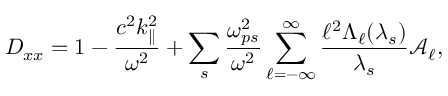Convert formula to latex. <formula><loc_0><loc_0><loc_500><loc_500>D _ { x x } = 1 - \frac { c ^ { 2 } k _ { \| } ^ { 2 } } { \omega ^ { 2 } } + \sum _ { s } \frac { \omega _ { p s } ^ { 2 } } { \omega ^ { 2 } } \sum _ { \ell = - \infty } ^ { \infty } \frac { \ell ^ { 2 } \Lambda _ { \ell } ( \lambda _ { s } ) } { \lambda _ { s } } \mathcal { A } _ { \ell } ,</formula> 